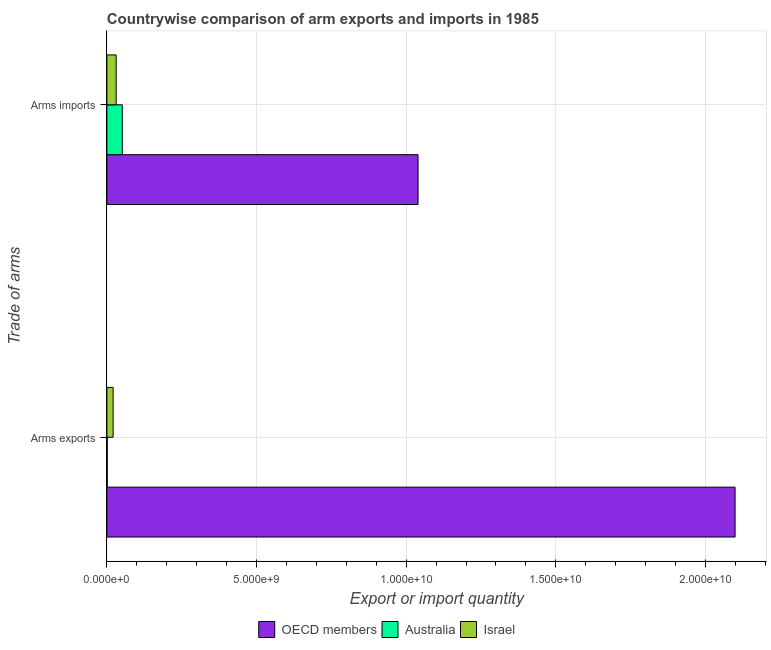How many different coloured bars are there?
Your answer should be compact. 3. How many bars are there on the 1st tick from the top?
Your response must be concise. 3. How many bars are there on the 2nd tick from the bottom?
Offer a terse response. 3. What is the label of the 1st group of bars from the top?
Provide a short and direct response. Arms imports. What is the arms imports in Australia?
Provide a succinct answer. 5.15e+08. Across all countries, what is the maximum arms imports?
Make the answer very short. 1.04e+1. Across all countries, what is the minimum arms exports?
Your answer should be compact. 1.30e+07. In which country was the arms imports maximum?
Your answer should be very brief. OECD members. What is the total arms exports in the graph?
Your answer should be compact. 2.12e+1. What is the difference between the arms imports in OECD members and that in Australia?
Ensure brevity in your answer.  9.88e+09. What is the difference between the arms exports in Israel and the arms imports in OECD members?
Keep it short and to the point. -1.02e+1. What is the average arms imports per country?
Your response must be concise. 3.74e+09. What is the difference between the arms imports and arms exports in Australia?
Offer a terse response. 5.02e+08. What is the ratio of the arms exports in OECD members to that in Israel?
Provide a short and direct response. 100.42. In how many countries, is the arms imports greater than the average arms imports taken over all countries?
Offer a very short reply. 1. What does the 1st bar from the top in Arms exports represents?
Your answer should be compact. Israel. What does the 3rd bar from the bottom in Arms imports represents?
Your answer should be compact. Israel. Are all the bars in the graph horizontal?
Offer a very short reply. Yes. How many legend labels are there?
Keep it short and to the point. 3. How are the legend labels stacked?
Provide a succinct answer. Horizontal. What is the title of the graph?
Your answer should be compact. Countrywise comparison of arm exports and imports in 1985. Does "Iran" appear as one of the legend labels in the graph?
Your response must be concise. No. What is the label or title of the X-axis?
Offer a very short reply. Export or import quantity. What is the label or title of the Y-axis?
Offer a very short reply. Trade of arms. What is the Export or import quantity in OECD members in Arms exports?
Provide a short and direct response. 2.10e+1. What is the Export or import quantity in Australia in Arms exports?
Your answer should be very brief. 1.30e+07. What is the Export or import quantity in Israel in Arms exports?
Your answer should be compact. 2.09e+08. What is the Export or import quantity in OECD members in Arms imports?
Provide a succinct answer. 1.04e+1. What is the Export or import quantity in Australia in Arms imports?
Offer a very short reply. 5.15e+08. What is the Export or import quantity in Israel in Arms imports?
Your answer should be compact. 3.10e+08. Across all Trade of arms, what is the maximum Export or import quantity in OECD members?
Give a very brief answer. 2.10e+1. Across all Trade of arms, what is the maximum Export or import quantity of Australia?
Make the answer very short. 5.15e+08. Across all Trade of arms, what is the maximum Export or import quantity in Israel?
Ensure brevity in your answer.  3.10e+08. Across all Trade of arms, what is the minimum Export or import quantity in OECD members?
Offer a very short reply. 1.04e+1. Across all Trade of arms, what is the minimum Export or import quantity of Australia?
Your answer should be compact. 1.30e+07. Across all Trade of arms, what is the minimum Export or import quantity of Israel?
Make the answer very short. 2.09e+08. What is the total Export or import quantity in OECD members in the graph?
Make the answer very short. 3.14e+1. What is the total Export or import quantity of Australia in the graph?
Your answer should be compact. 5.28e+08. What is the total Export or import quantity of Israel in the graph?
Offer a terse response. 5.19e+08. What is the difference between the Export or import quantity in OECD members in Arms exports and that in Arms imports?
Ensure brevity in your answer.  1.06e+1. What is the difference between the Export or import quantity of Australia in Arms exports and that in Arms imports?
Your answer should be very brief. -5.02e+08. What is the difference between the Export or import quantity in Israel in Arms exports and that in Arms imports?
Your answer should be very brief. -1.01e+08. What is the difference between the Export or import quantity of OECD members in Arms exports and the Export or import quantity of Australia in Arms imports?
Give a very brief answer. 2.05e+1. What is the difference between the Export or import quantity in OECD members in Arms exports and the Export or import quantity in Israel in Arms imports?
Provide a succinct answer. 2.07e+1. What is the difference between the Export or import quantity in Australia in Arms exports and the Export or import quantity in Israel in Arms imports?
Your answer should be compact. -2.97e+08. What is the average Export or import quantity of OECD members per Trade of arms?
Make the answer very short. 1.57e+1. What is the average Export or import quantity of Australia per Trade of arms?
Your response must be concise. 2.64e+08. What is the average Export or import quantity of Israel per Trade of arms?
Offer a very short reply. 2.60e+08. What is the difference between the Export or import quantity of OECD members and Export or import quantity of Australia in Arms exports?
Provide a succinct answer. 2.10e+1. What is the difference between the Export or import quantity of OECD members and Export or import quantity of Israel in Arms exports?
Give a very brief answer. 2.08e+1. What is the difference between the Export or import quantity in Australia and Export or import quantity in Israel in Arms exports?
Your answer should be compact. -1.96e+08. What is the difference between the Export or import quantity in OECD members and Export or import quantity in Australia in Arms imports?
Offer a very short reply. 9.88e+09. What is the difference between the Export or import quantity in OECD members and Export or import quantity in Israel in Arms imports?
Make the answer very short. 1.01e+1. What is the difference between the Export or import quantity of Australia and Export or import quantity of Israel in Arms imports?
Give a very brief answer. 2.05e+08. What is the ratio of the Export or import quantity of OECD members in Arms exports to that in Arms imports?
Give a very brief answer. 2.02. What is the ratio of the Export or import quantity of Australia in Arms exports to that in Arms imports?
Provide a short and direct response. 0.03. What is the ratio of the Export or import quantity in Israel in Arms exports to that in Arms imports?
Give a very brief answer. 0.67. What is the difference between the highest and the second highest Export or import quantity in OECD members?
Ensure brevity in your answer.  1.06e+1. What is the difference between the highest and the second highest Export or import quantity in Australia?
Provide a short and direct response. 5.02e+08. What is the difference between the highest and the second highest Export or import quantity of Israel?
Make the answer very short. 1.01e+08. What is the difference between the highest and the lowest Export or import quantity of OECD members?
Ensure brevity in your answer.  1.06e+1. What is the difference between the highest and the lowest Export or import quantity of Australia?
Provide a succinct answer. 5.02e+08. What is the difference between the highest and the lowest Export or import quantity in Israel?
Offer a terse response. 1.01e+08. 